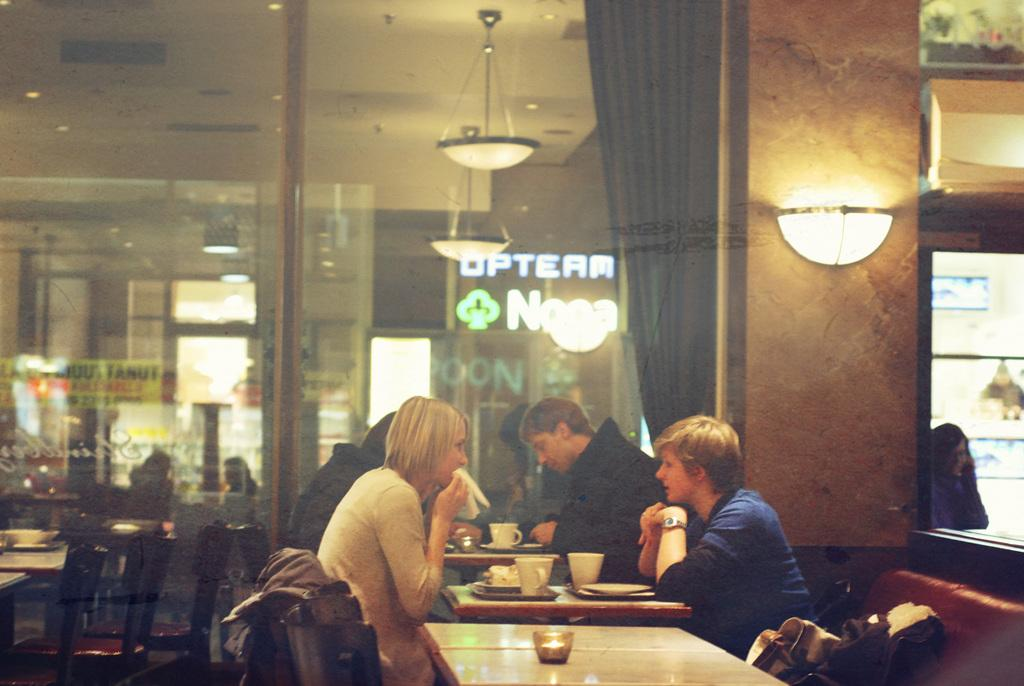What are the people in the image doing? The people in the image are sitting on chairs. What is present on the table in the image? There is a coffee mug and a bowl with food items on the table. Can you describe the table in the image? The table is a piece of furniture where the coffee mug and bowl with food items are placed. What type of tree can be seen growing near the river in the image? There is no tree or river present in the image; it features people sitting on chairs with a table containing a coffee mug and a bowl with food items. 